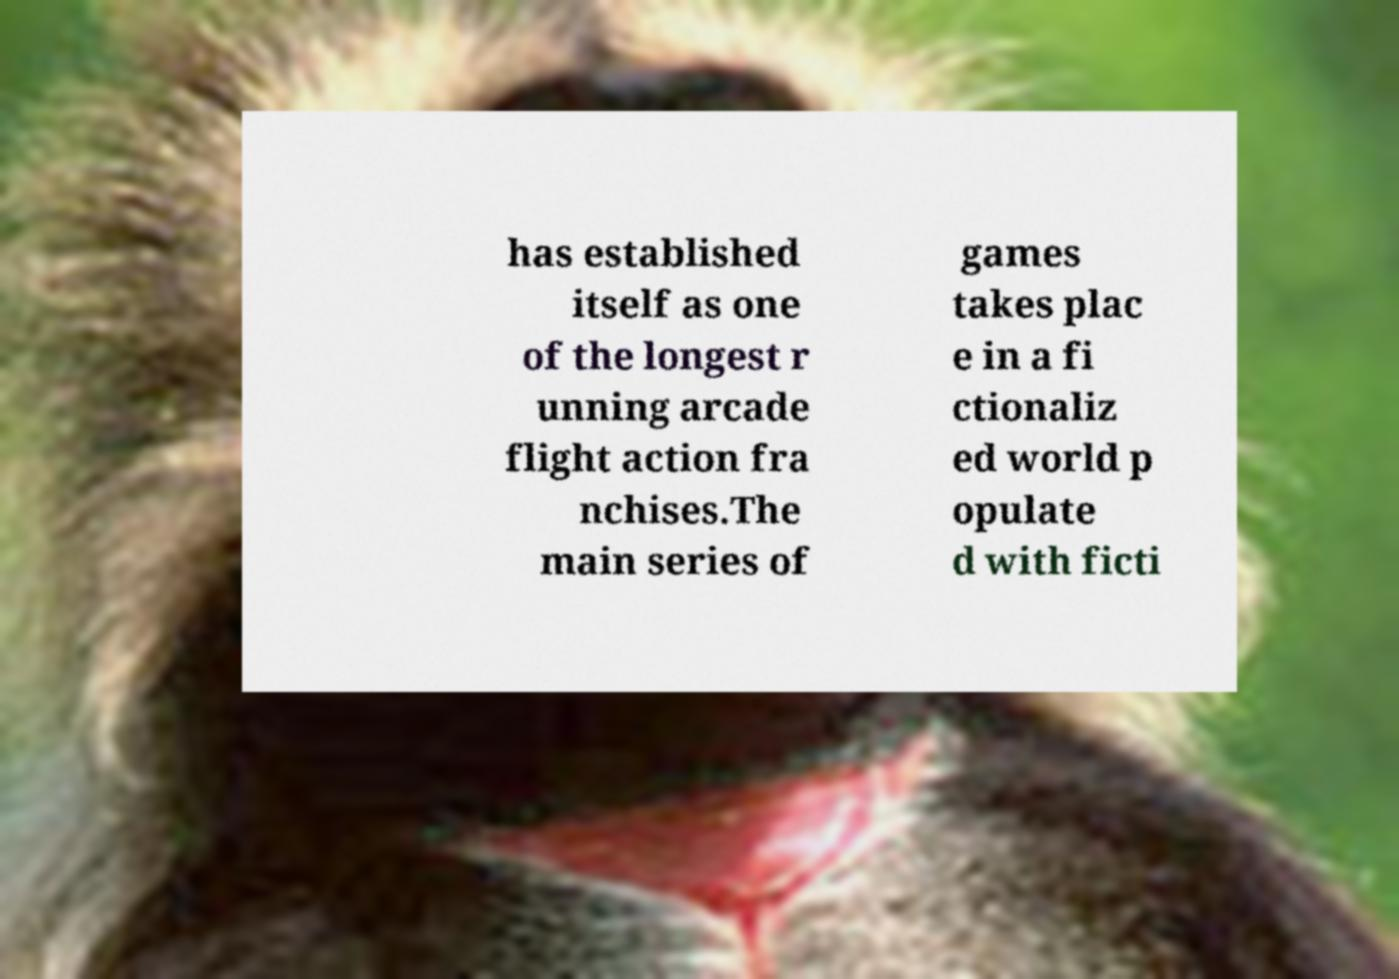Please identify and transcribe the text found in this image. has established itself as one of the longest r unning arcade flight action fra nchises.The main series of games takes plac e in a fi ctionaliz ed world p opulate d with ficti 